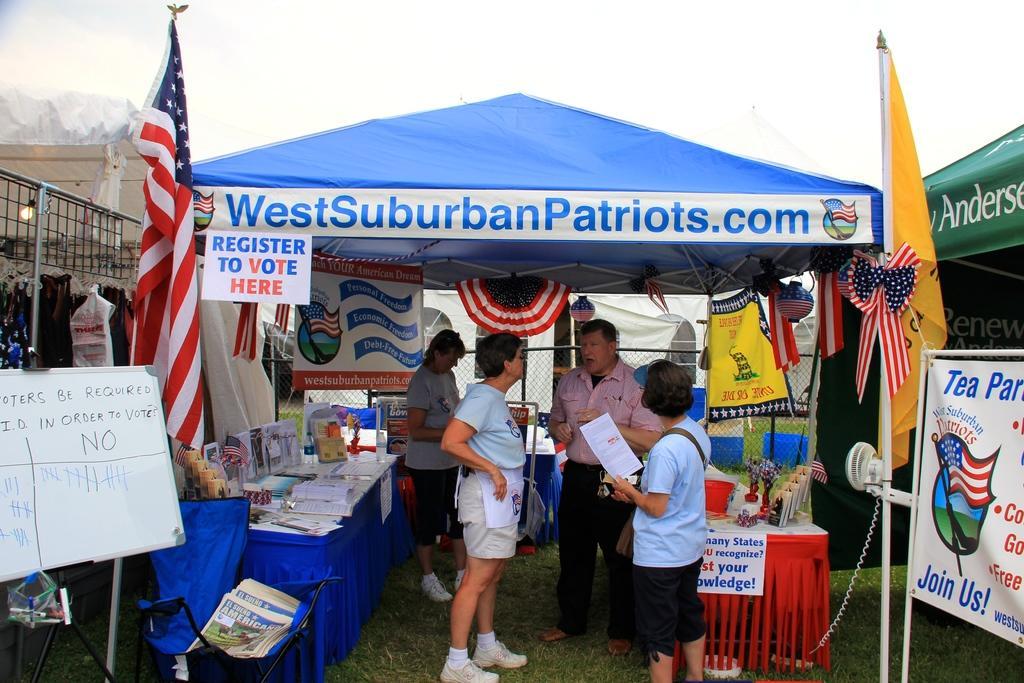Can you describe this image briefly? In the center of the image there is a stall. There are people standing. There are flags. To the left side of the image there is a board with some text. There is a banner. At the top of the image there is sky. 